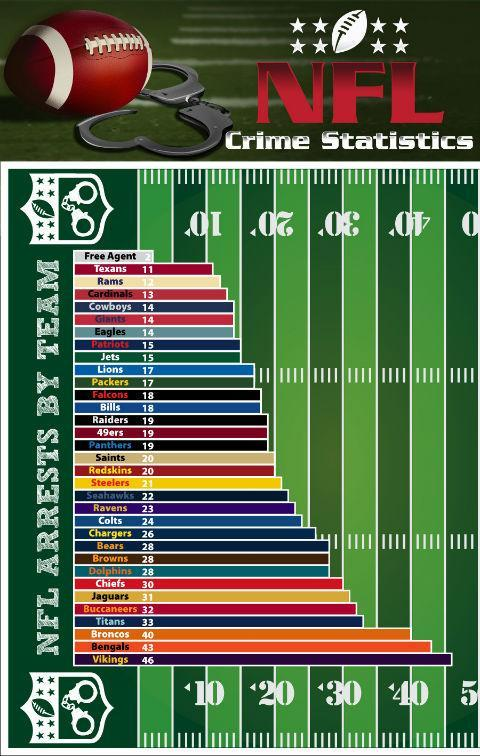Which NFL teams have had less than 10 arrests?
Answer the question with a short phrase. Free agent Which NFL teams has had more than 40 arrests? Bengals, Vikings Which NFL teams had 14 arrests recorded? Cowboys, Giants, Eagles 